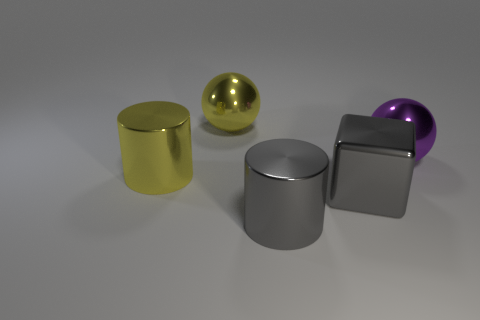Add 5 big cylinders. How many objects exist? 10 Subtract all blocks. How many objects are left? 4 Subtract all gray cylinders. How many cylinders are left? 1 Subtract 1 cylinders. How many cylinders are left? 1 Subtract all cyan cylinders. Subtract all red spheres. How many cylinders are left? 2 Subtract all yellow cubes. How many yellow cylinders are left? 1 Subtract all blocks. Subtract all big purple things. How many objects are left? 3 Add 5 gray metallic cylinders. How many gray metallic cylinders are left? 6 Add 2 metallic cubes. How many metallic cubes exist? 3 Subtract 0 gray spheres. How many objects are left? 5 